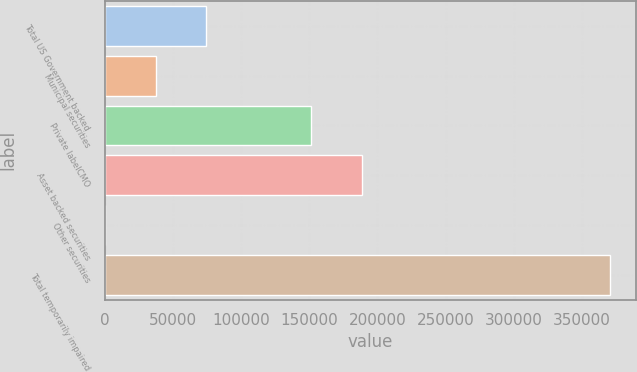Convert chart to OTSL. <chart><loc_0><loc_0><loc_500><loc_500><bar_chart><fcel>Total US Government backed<fcel>Municipal securities<fcel>Private labelCMO<fcel>Asset backed securities<fcel>Other securities<fcel>Total temporarily impaired<nl><fcel>74603.8<fcel>37558.9<fcel>150991<fcel>188854<fcel>514<fcel>370963<nl></chart> 